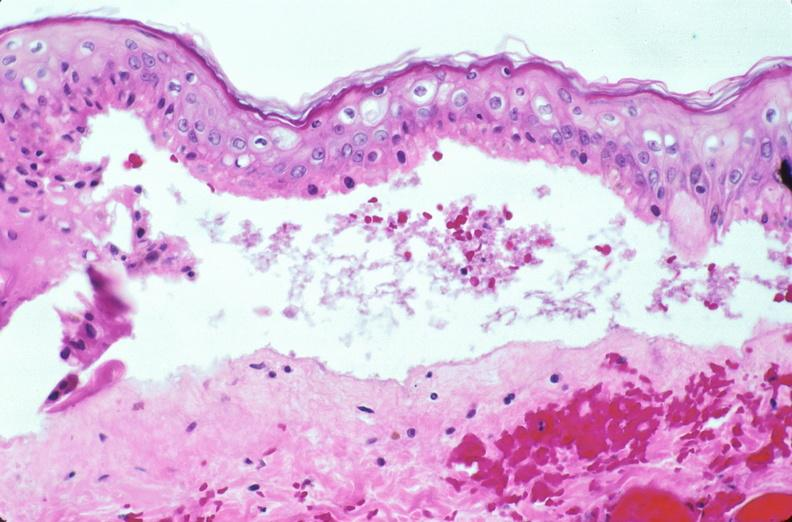what does this image show?
Answer the question using a single word or phrase. Skin 